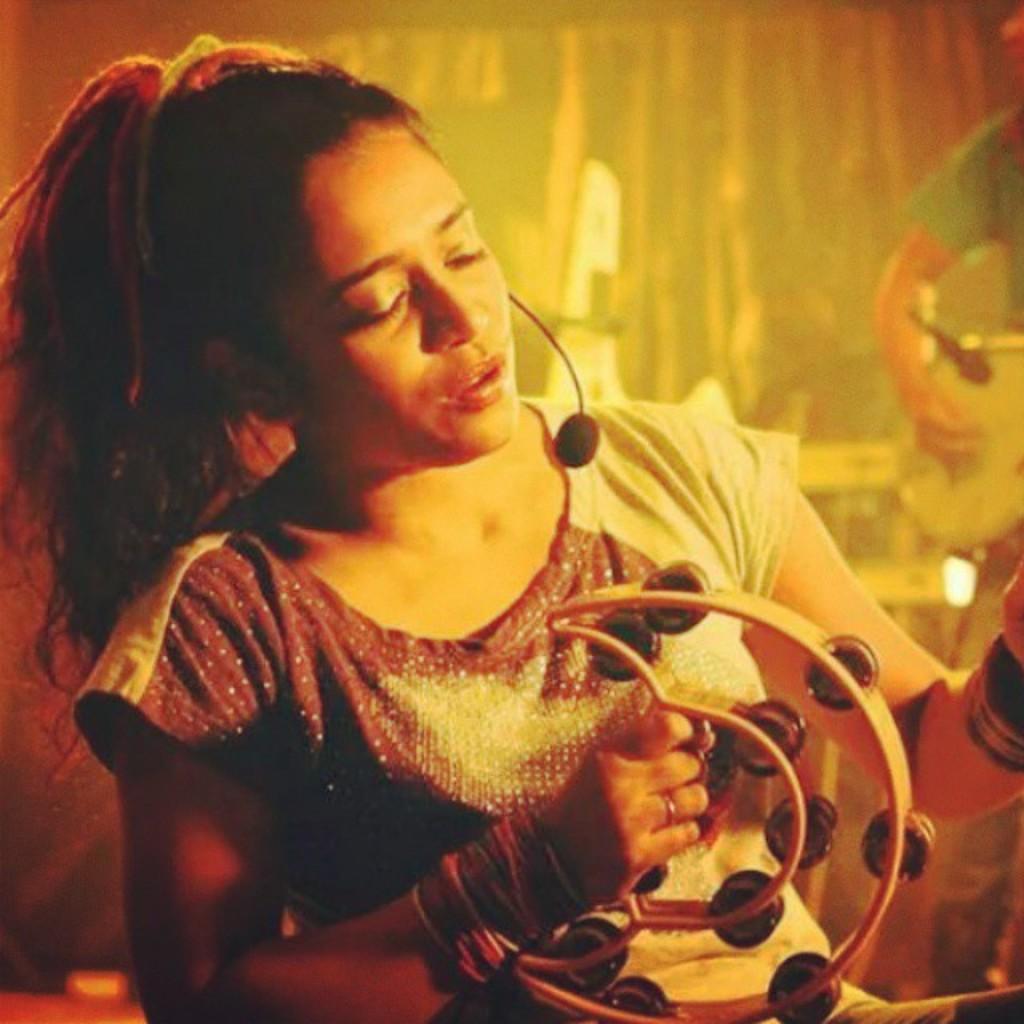Describe this image in one or two sentences. In this image we can see a lady holding a musical instrument. And there is a mic on her face. In the back there is another person holding a musical instrument. And there is a mic. In the background it is blur. 